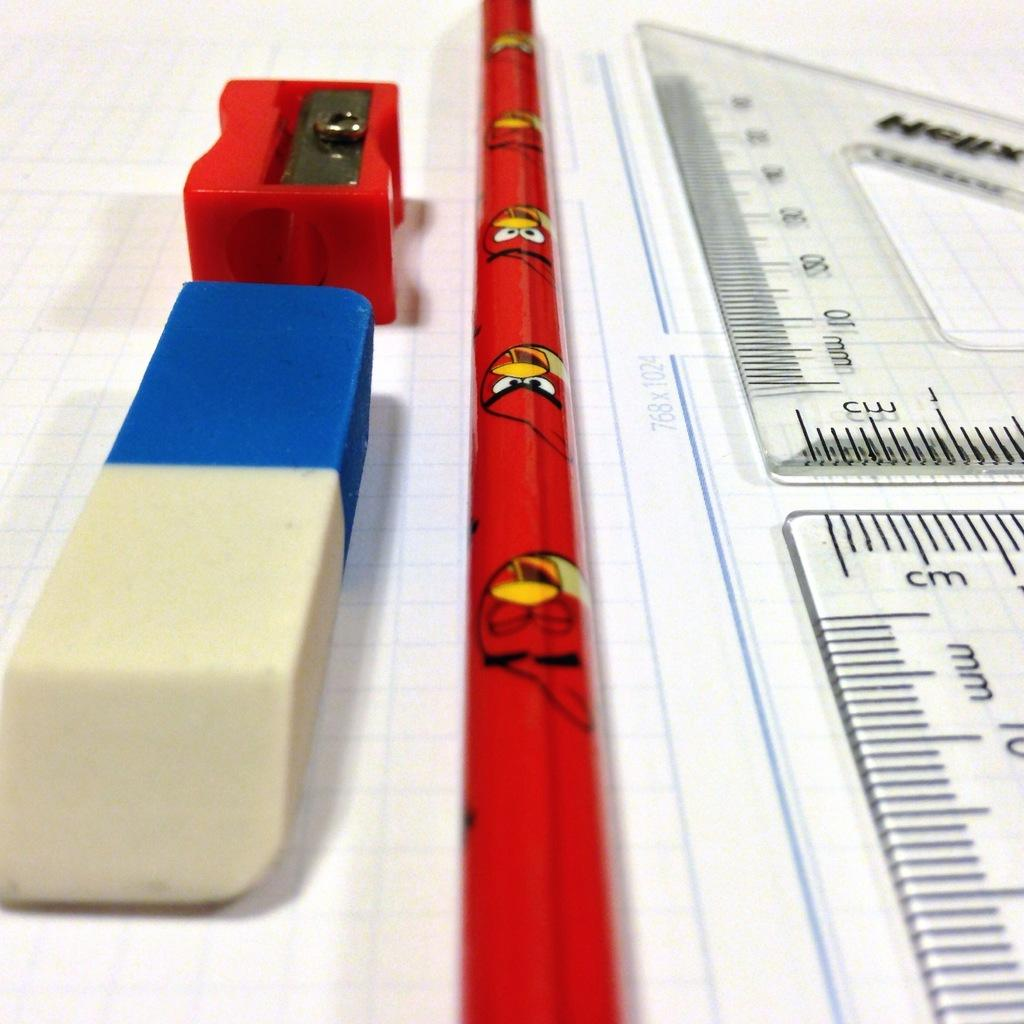<image>
Share a concise interpretation of the image provided. the word cm that is on a ruler 